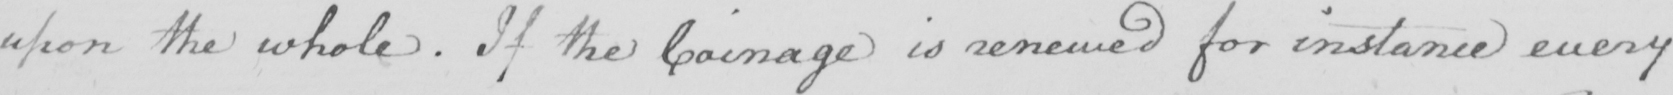Please provide the text content of this handwritten line. upon the whole . If the Coinage is renewed for instance every 